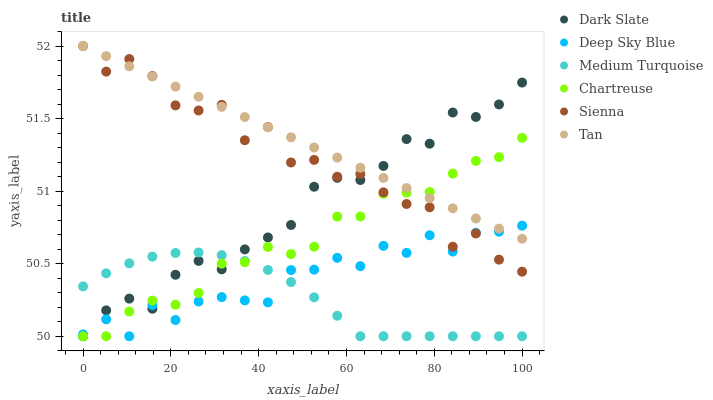Does Medium Turquoise have the minimum area under the curve?
Answer yes or no. Yes. Does Tan have the maximum area under the curve?
Answer yes or no. Yes. Does Sienna have the minimum area under the curve?
Answer yes or no. No. Does Sienna have the maximum area under the curve?
Answer yes or no. No. Is Tan the smoothest?
Answer yes or no. Yes. Is Sienna the roughest?
Answer yes or no. Yes. Is Dark Slate the smoothest?
Answer yes or no. No. Is Dark Slate the roughest?
Answer yes or no. No. Does Deep Sky Blue have the lowest value?
Answer yes or no. Yes. Does Sienna have the lowest value?
Answer yes or no. No. Does Tan have the highest value?
Answer yes or no. Yes. Does Dark Slate have the highest value?
Answer yes or no. No. Is Medium Turquoise less than Sienna?
Answer yes or no. Yes. Is Tan greater than Medium Turquoise?
Answer yes or no. Yes. Does Chartreuse intersect Dark Slate?
Answer yes or no. Yes. Is Chartreuse less than Dark Slate?
Answer yes or no. No. Is Chartreuse greater than Dark Slate?
Answer yes or no. No. Does Medium Turquoise intersect Sienna?
Answer yes or no. No. 